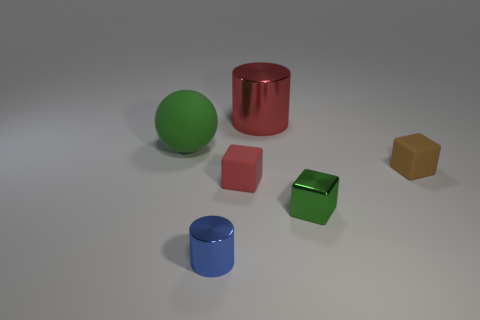Are there any other things that are the same color as the sphere?
Keep it short and to the point. Yes. How big is the green thing that is on the right side of the red thing in front of the green thing that is behind the green metal block?
Make the answer very short. Small. What material is the green thing on the right side of the red shiny cylinder that is behind the matte block that is behind the tiny red rubber thing?
Ensure brevity in your answer.  Metal. What is the shape of the red object that is the same size as the blue cylinder?
Give a very brief answer. Cube. What number of tiny objects are both to the left of the tiny green cube and behind the small metal block?
Ensure brevity in your answer.  1. There is a big object that is the same material as the small green thing; what is its color?
Offer a terse response. Red. There is a object that is both in front of the tiny red cube and on the right side of the large cylinder; what material is it made of?
Your answer should be compact. Metal. What number of metal blocks are the same color as the matte sphere?
Your answer should be very brief. 1. What is the material of the cube that is the same color as the large matte sphere?
Make the answer very short. Metal. Does the tiny metal block have the same color as the big thing in front of the red metal thing?
Provide a short and direct response. Yes. 